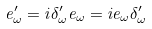<formula> <loc_0><loc_0><loc_500><loc_500>e _ { \omega } ^ { \prime } = i \delta _ { \omega } ^ { \prime } e _ { \omega } = i e _ { \omega } \delta _ { \omega } ^ { \prime }</formula> 